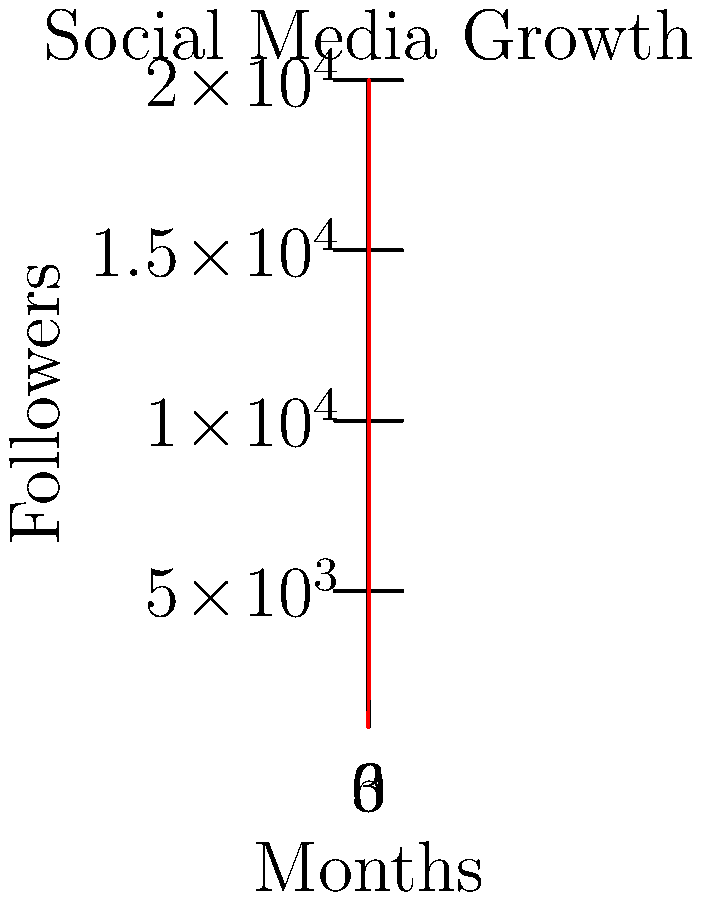As an emerging singer-songwriter, you've been tracking your social media follower growth over the past 6 months. The graph shows your follower count increase since you started performing at the rival club. If this growth trend continues, approximately how many followers can you expect to have 3 months from now? To solve this problem, we need to analyze the growth trend and extrapolate it for the next 3 months. Let's break it down step-by-step:

1. Observe the graph: The line shows exponential growth, not linear.

2. Calculate the growth rate:
   - Initial followers (month 0): 1,000
   - Final followers (month 6): 20,000
   - Growth factor over 6 months: 20,000 / 1,000 = 20

3. Calculate the monthly growth rate:
   $\sqrt[6]{20} \approx 1.68$ (rounded to 2 decimal places)

4. This means the follower count is increasing by about 68% each month.

5. To project 3 months into the future:
   20,000 * $(1.68)^3 \approx 94,500$

Therefore, if the growth trend continues, you can expect approximately 94,500 followers in 3 months.
Answer: Approximately 94,500 followers 